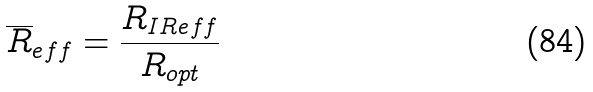Convert formula to latex. <formula><loc_0><loc_0><loc_500><loc_500>\overline { R } _ { e f f } = \frac { R _ { I R e f f } } { R _ { o p t } }</formula> 